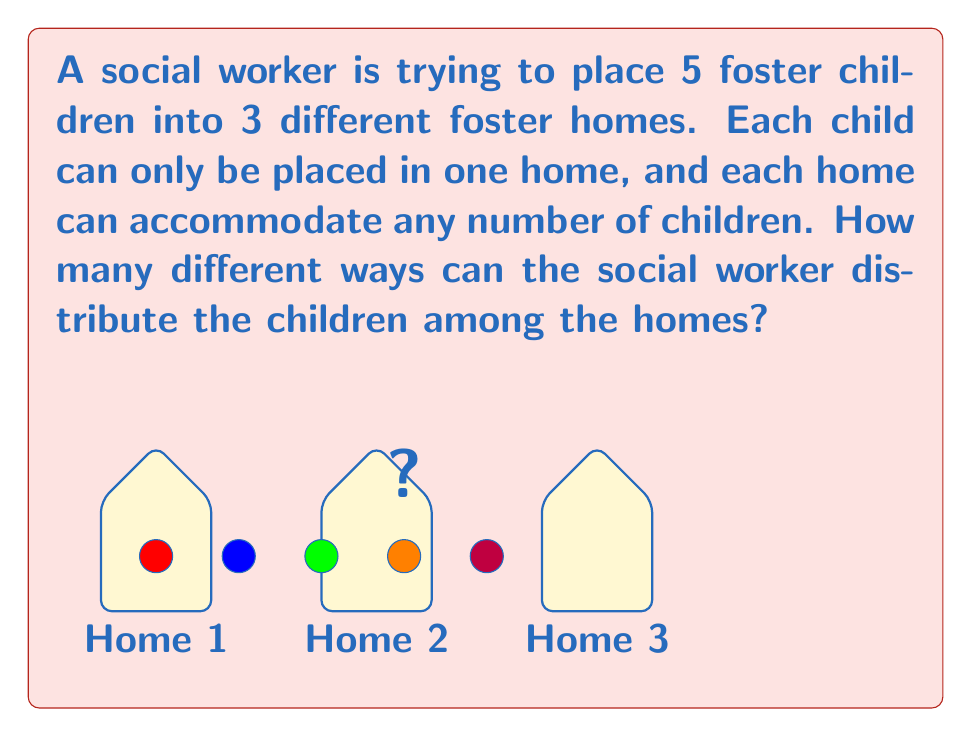Can you answer this question? To solve this problem, we can use the concept of partitions in combinatorics. Each possible distribution of children can be thought of as a partition of the set of 5 children into 3 or fewer subsets (homes).

Let's approach this step-by-step:

1) First, we need to recognize that this is equivalent to the number of ways to put 5 identical objects into 3 distinct boxes, allowing for empty boxes. This is a classic stars and bars problem.

2) The formula for this scenario is:
   $${n+k-1 \choose k-1}$$
   where $n$ is the number of identical objects (children) and $k$ is the number of distinct boxes (homes).

3) In our case, $n = 5$ (children) and $k = 3$ (homes).

4) Plugging these values into the formula:
   $${5+3-1 \choose 3-1} = {7 \choose 2}$$

5) We can calculate this as:
   $${7 \choose 2} = \frac{7!}{2!(7-2)!} = \frac{7 \cdot 6}{2 \cdot 1} = 21$$

Therefore, there are 21 different ways to distribute the 5 children among the 3 foster homes.
Answer: 21 